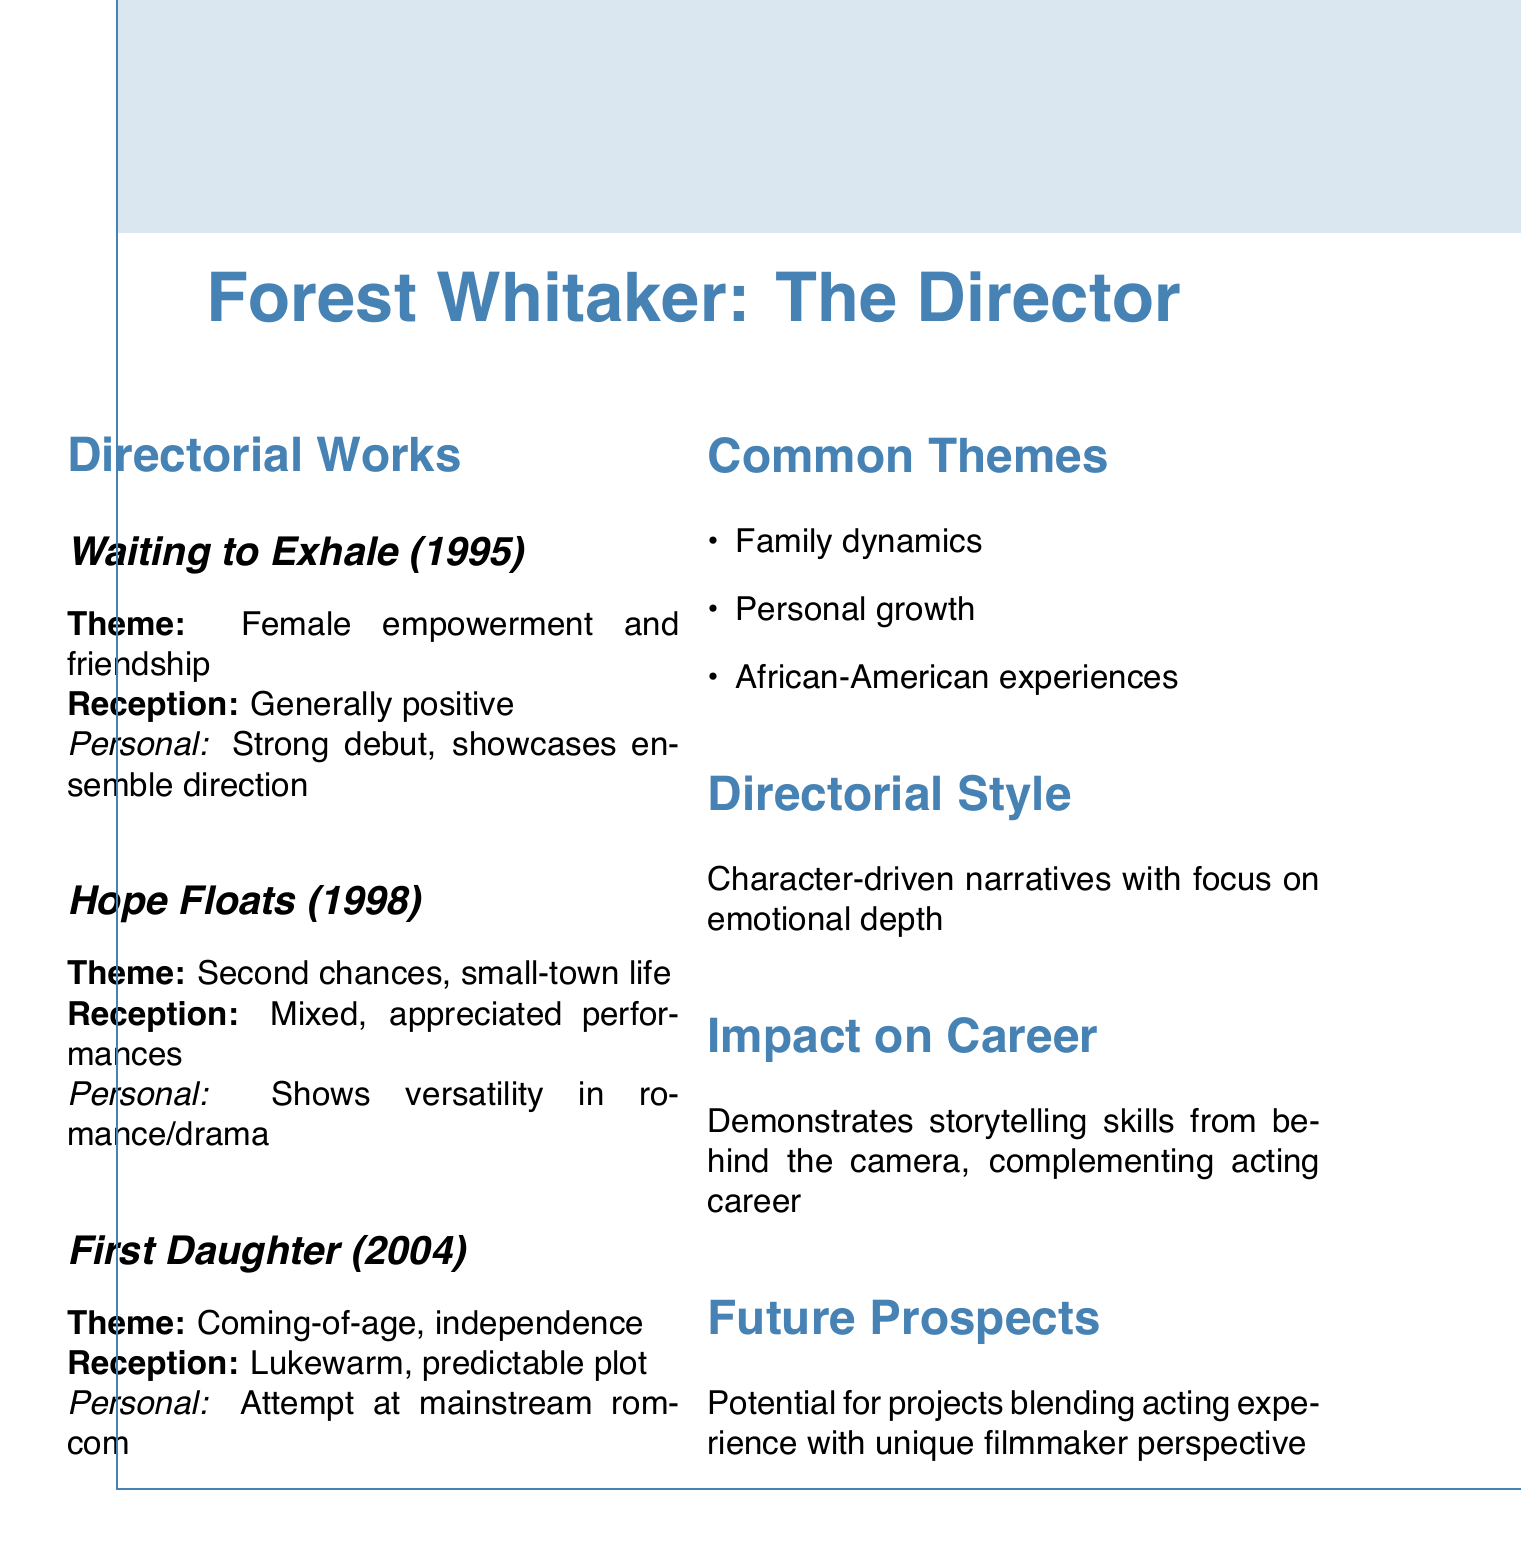What is the title of Forest Whitaker's 1995 directorial work? The title of his 1995 directorial work is explicitly listed in the document.
Answer: Waiting to Exhale What theme is explored in "Hope Floats"? The theme for "Hope Floats" is identified clearly, focusing on the central idea portrayed in the film.
Answer: Second chances and small-town life How was "First Daughter" received critically? The critical reception of "First Daughter" is stated directly in the document, summarizing the overall opinion.
Answer: Lukewarm reception What is a common theme across Forest Whitaker's directorial works? The document lists several common themes; one of them reflects similar ideas in his works.
Answer: Family dynamics Which year was "Waiting to Exhale" released? The document clearly states the release year of "Waiting to Exhale."
Answer: 1995 What is the main focus of Whitaker's directorial style? The directorial style is summarized in the document, emphasizing what he aims to achieve through his direction.
Answer: Emotional depth How did "Hope Floats" perform critically? "Hope Floats" is mentioned to have received mixed reviews, which is an essential aspect of its evaluation.
Answer: Mixed reviews What impact has Whitaker's directing had on his career? The document explains the significance of his directorial works in relation to his overall career.
Answer: Understanding of storytelling from behind the camera What type of narratives does Whitaker tend to focus on? The style section of the document indicates the type of narratives Whitaker emphasizes in his directorial works.
Answer: Character-driven narratives 